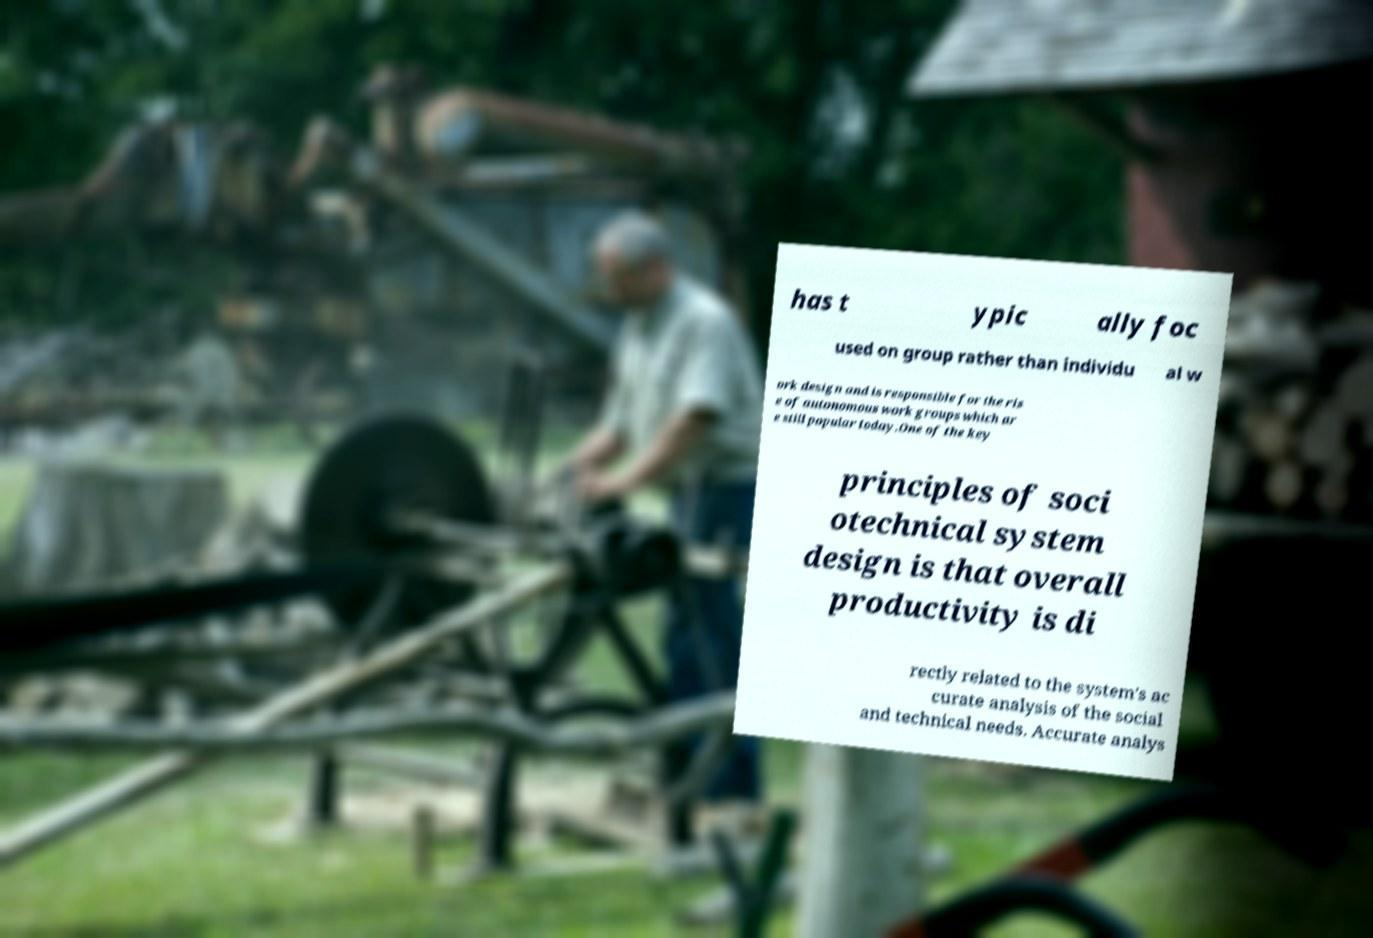What messages or text are displayed in this image? I need them in a readable, typed format. has t ypic ally foc used on group rather than individu al w ork design and is responsible for the ris e of autonomous work groups which ar e still popular today.One of the key principles of soci otechnical system design is that overall productivity is di rectly related to the system's ac curate analysis of the social and technical needs. Accurate analys 